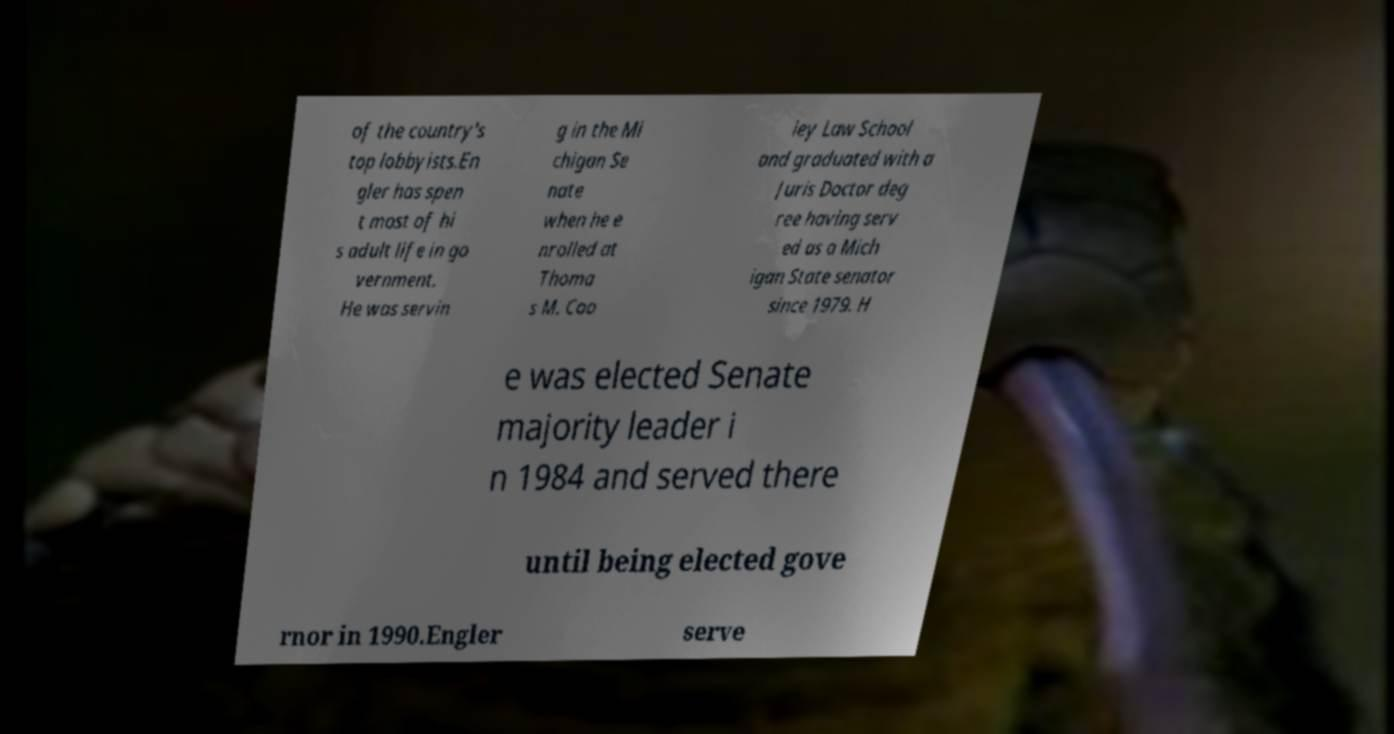Could you extract and type out the text from this image? of the country's top lobbyists.En gler has spen t most of hi s adult life in go vernment. He was servin g in the Mi chigan Se nate when he e nrolled at Thoma s M. Coo ley Law School and graduated with a Juris Doctor deg ree having serv ed as a Mich igan State senator since 1979. H e was elected Senate majority leader i n 1984 and served there until being elected gove rnor in 1990.Engler serve 